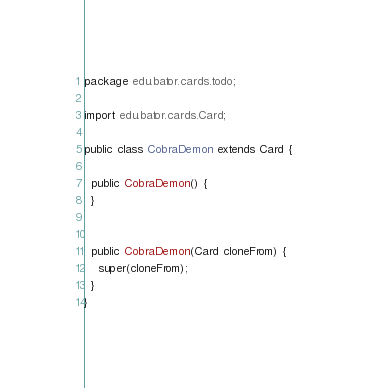Convert code to text. <code><loc_0><loc_0><loc_500><loc_500><_Java_>package edu.bator.cards.todo;

import edu.bator.cards.Card;

public class CobraDemon extends Card {

  public CobraDemon() {
  }


  public CobraDemon(Card cloneFrom) {
    super(cloneFrom);
  }
}
</code> 